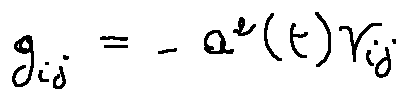<formula> <loc_0><loc_0><loc_500><loc_500>g _ { i j } = - a ^ { 2 } ( t ) \gamma _ { i j }</formula> 